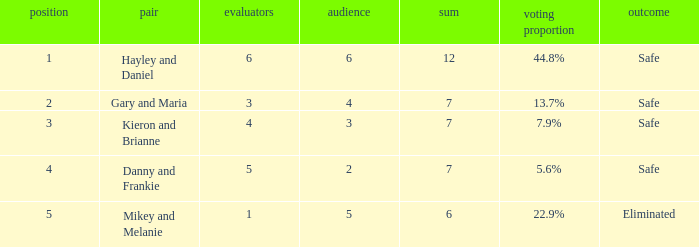What is the number of public that was there when the vote percentage was 22.9%? 1.0. 